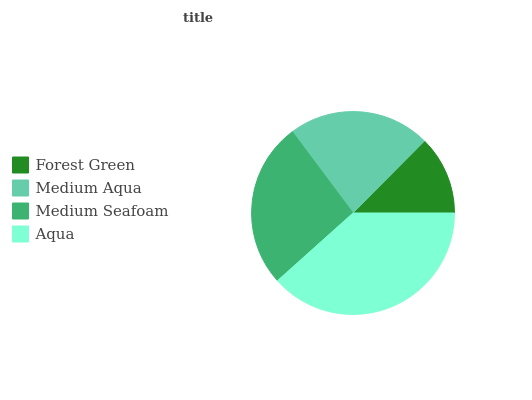Is Forest Green the minimum?
Answer yes or no. Yes. Is Aqua the maximum?
Answer yes or no. Yes. Is Medium Aqua the minimum?
Answer yes or no. No. Is Medium Aqua the maximum?
Answer yes or no. No. Is Medium Aqua greater than Forest Green?
Answer yes or no. Yes. Is Forest Green less than Medium Aqua?
Answer yes or no. Yes. Is Forest Green greater than Medium Aqua?
Answer yes or no. No. Is Medium Aqua less than Forest Green?
Answer yes or no. No. Is Medium Seafoam the high median?
Answer yes or no. Yes. Is Medium Aqua the low median?
Answer yes or no. Yes. Is Aqua the high median?
Answer yes or no. No. Is Aqua the low median?
Answer yes or no. No. 